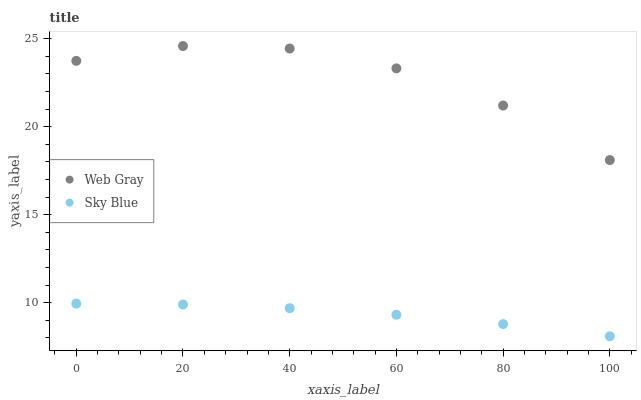Does Sky Blue have the minimum area under the curve?
Answer yes or no. Yes. Does Web Gray have the maximum area under the curve?
Answer yes or no. Yes. Does Web Gray have the minimum area under the curve?
Answer yes or no. No. Is Sky Blue the smoothest?
Answer yes or no. Yes. Is Web Gray the roughest?
Answer yes or no. Yes. Is Web Gray the smoothest?
Answer yes or no. No. Does Sky Blue have the lowest value?
Answer yes or no. Yes. Does Web Gray have the lowest value?
Answer yes or no. No. Does Web Gray have the highest value?
Answer yes or no. Yes. Is Sky Blue less than Web Gray?
Answer yes or no. Yes. Is Web Gray greater than Sky Blue?
Answer yes or no. Yes. Does Sky Blue intersect Web Gray?
Answer yes or no. No. 